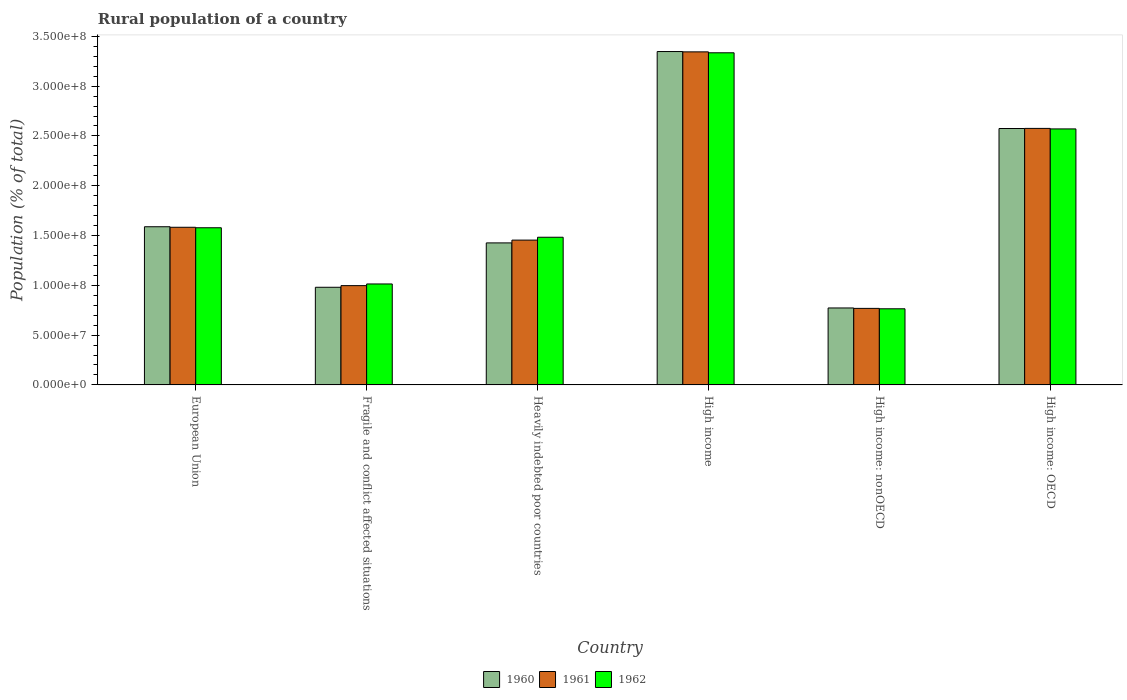How many groups of bars are there?
Your answer should be compact. 6. Are the number of bars per tick equal to the number of legend labels?
Ensure brevity in your answer.  Yes. Are the number of bars on each tick of the X-axis equal?
Make the answer very short. Yes. How many bars are there on the 4th tick from the left?
Your answer should be compact. 3. How many bars are there on the 5th tick from the right?
Ensure brevity in your answer.  3. What is the label of the 4th group of bars from the left?
Provide a succinct answer. High income. In how many cases, is the number of bars for a given country not equal to the number of legend labels?
Provide a short and direct response. 0. What is the rural population in 1961 in High income: OECD?
Offer a terse response. 2.58e+08. Across all countries, what is the maximum rural population in 1962?
Offer a terse response. 3.33e+08. Across all countries, what is the minimum rural population in 1962?
Your answer should be very brief. 7.64e+07. In which country was the rural population in 1960 maximum?
Offer a terse response. High income. In which country was the rural population in 1960 minimum?
Your answer should be compact. High income: nonOECD. What is the total rural population in 1962 in the graph?
Make the answer very short. 1.07e+09. What is the difference between the rural population in 1960 in European Union and that in Heavily indebted poor countries?
Offer a terse response. 1.62e+07. What is the difference between the rural population in 1962 in Fragile and conflict affected situations and the rural population in 1960 in High income: OECD?
Provide a short and direct response. -1.56e+08. What is the average rural population in 1960 per country?
Your answer should be compact. 1.78e+08. What is the difference between the rural population of/in 1962 and rural population of/in 1960 in European Union?
Your answer should be compact. -1.02e+06. In how many countries, is the rural population in 1960 greater than 20000000 %?
Offer a very short reply. 6. What is the ratio of the rural population in 1960 in Fragile and conflict affected situations to that in High income: OECD?
Provide a succinct answer. 0.38. Is the rural population in 1960 in Fragile and conflict affected situations less than that in High income: OECD?
Give a very brief answer. Yes. What is the difference between the highest and the second highest rural population in 1961?
Ensure brevity in your answer.  7.69e+07. What is the difference between the highest and the lowest rural population in 1961?
Provide a short and direct response. 2.58e+08. In how many countries, is the rural population in 1960 greater than the average rural population in 1960 taken over all countries?
Ensure brevity in your answer.  2. Is it the case that in every country, the sum of the rural population in 1961 and rural population in 1960 is greater than the rural population in 1962?
Provide a succinct answer. Yes. How many countries are there in the graph?
Your answer should be very brief. 6. Where does the legend appear in the graph?
Offer a terse response. Bottom center. What is the title of the graph?
Provide a succinct answer. Rural population of a country. Does "1960" appear as one of the legend labels in the graph?
Offer a very short reply. Yes. What is the label or title of the Y-axis?
Provide a succinct answer. Population (% of total). What is the Population (% of total) in 1960 in European Union?
Keep it short and to the point. 1.59e+08. What is the Population (% of total) in 1961 in European Union?
Keep it short and to the point. 1.58e+08. What is the Population (% of total) of 1962 in European Union?
Offer a very short reply. 1.58e+08. What is the Population (% of total) in 1960 in Fragile and conflict affected situations?
Offer a terse response. 9.80e+07. What is the Population (% of total) of 1961 in Fragile and conflict affected situations?
Your answer should be very brief. 9.97e+07. What is the Population (% of total) of 1962 in Fragile and conflict affected situations?
Your answer should be very brief. 1.01e+08. What is the Population (% of total) in 1960 in Heavily indebted poor countries?
Give a very brief answer. 1.43e+08. What is the Population (% of total) in 1961 in Heavily indebted poor countries?
Your answer should be compact. 1.45e+08. What is the Population (% of total) of 1962 in Heavily indebted poor countries?
Offer a terse response. 1.48e+08. What is the Population (% of total) of 1960 in High income?
Keep it short and to the point. 3.35e+08. What is the Population (% of total) of 1961 in High income?
Make the answer very short. 3.34e+08. What is the Population (% of total) in 1962 in High income?
Your response must be concise. 3.33e+08. What is the Population (% of total) of 1960 in High income: nonOECD?
Provide a succinct answer. 7.73e+07. What is the Population (% of total) in 1961 in High income: nonOECD?
Offer a terse response. 7.69e+07. What is the Population (% of total) in 1962 in High income: nonOECD?
Make the answer very short. 7.64e+07. What is the Population (% of total) of 1960 in High income: OECD?
Make the answer very short. 2.57e+08. What is the Population (% of total) in 1961 in High income: OECD?
Keep it short and to the point. 2.58e+08. What is the Population (% of total) in 1962 in High income: OECD?
Provide a short and direct response. 2.57e+08. Across all countries, what is the maximum Population (% of total) in 1960?
Your answer should be very brief. 3.35e+08. Across all countries, what is the maximum Population (% of total) in 1961?
Your answer should be compact. 3.34e+08. Across all countries, what is the maximum Population (% of total) in 1962?
Provide a succinct answer. 3.33e+08. Across all countries, what is the minimum Population (% of total) of 1960?
Keep it short and to the point. 7.73e+07. Across all countries, what is the minimum Population (% of total) in 1961?
Offer a terse response. 7.69e+07. Across all countries, what is the minimum Population (% of total) in 1962?
Provide a succinct answer. 7.64e+07. What is the total Population (% of total) in 1960 in the graph?
Provide a succinct answer. 1.07e+09. What is the total Population (% of total) in 1961 in the graph?
Provide a succinct answer. 1.07e+09. What is the total Population (% of total) in 1962 in the graph?
Keep it short and to the point. 1.07e+09. What is the difference between the Population (% of total) in 1960 in European Union and that in Fragile and conflict affected situations?
Offer a very short reply. 6.08e+07. What is the difference between the Population (% of total) in 1961 in European Union and that in Fragile and conflict affected situations?
Offer a very short reply. 5.86e+07. What is the difference between the Population (% of total) in 1962 in European Union and that in Fragile and conflict affected situations?
Provide a succinct answer. 5.64e+07. What is the difference between the Population (% of total) in 1960 in European Union and that in Heavily indebted poor countries?
Offer a very short reply. 1.62e+07. What is the difference between the Population (% of total) of 1961 in European Union and that in Heavily indebted poor countries?
Your response must be concise. 1.29e+07. What is the difference between the Population (% of total) in 1962 in European Union and that in Heavily indebted poor countries?
Your answer should be compact. 9.52e+06. What is the difference between the Population (% of total) in 1960 in European Union and that in High income?
Keep it short and to the point. -1.76e+08. What is the difference between the Population (% of total) in 1961 in European Union and that in High income?
Make the answer very short. -1.76e+08. What is the difference between the Population (% of total) of 1962 in European Union and that in High income?
Offer a very short reply. -1.76e+08. What is the difference between the Population (% of total) of 1960 in European Union and that in High income: nonOECD?
Your response must be concise. 8.16e+07. What is the difference between the Population (% of total) in 1961 in European Union and that in High income: nonOECD?
Give a very brief answer. 8.14e+07. What is the difference between the Population (% of total) in 1962 in European Union and that in High income: nonOECD?
Ensure brevity in your answer.  8.14e+07. What is the difference between the Population (% of total) in 1960 in European Union and that in High income: OECD?
Make the answer very short. -9.86e+07. What is the difference between the Population (% of total) of 1961 in European Union and that in High income: OECD?
Keep it short and to the point. -9.93e+07. What is the difference between the Population (% of total) of 1962 in European Union and that in High income: OECD?
Your response must be concise. -9.93e+07. What is the difference between the Population (% of total) in 1960 in Fragile and conflict affected situations and that in Heavily indebted poor countries?
Give a very brief answer. -4.46e+07. What is the difference between the Population (% of total) in 1961 in Fragile and conflict affected situations and that in Heavily indebted poor countries?
Provide a succinct answer. -4.57e+07. What is the difference between the Population (% of total) in 1962 in Fragile and conflict affected situations and that in Heavily indebted poor countries?
Your answer should be very brief. -4.69e+07. What is the difference between the Population (% of total) in 1960 in Fragile and conflict affected situations and that in High income?
Offer a terse response. -2.37e+08. What is the difference between the Population (% of total) of 1961 in Fragile and conflict affected situations and that in High income?
Provide a short and direct response. -2.35e+08. What is the difference between the Population (% of total) in 1962 in Fragile and conflict affected situations and that in High income?
Your answer should be very brief. -2.32e+08. What is the difference between the Population (% of total) in 1960 in Fragile and conflict affected situations and that in High income: nonOECD?
Provide a short and direct response. 2.08e+07. What is the difference between the Population (% of total) of 1961 in Fragile and conflict affected situations and that in High income: nonOECD?
Offer a very short reply. 2.28e+07. What is the difference between the Population (% of total) of 1962 in Fragile and conflict affected situations and that in High income: nonOECD?
Your response must be concise. 2.49e+07. What is the difference between the Population (% of total) in 1960 in Fragile and conflict affected situations and that in High income: OECD?
Ensure brevity in your answer.  -1.59e+08. What is the difference between the Population (% of total) of 1961 in Fragile and conflict affected situations and that in High income: OECD?
Provide a short and direct response. -1.58e+08. What is the difference between the Population (% of total) of 1962 in Fragile and conflict affected situations and that in High income: OECD?
Your answer should be compact. -1.56e+08. What is the difference between the Population (% of total) in 1960 in Heavily indebted poor countries and that in High income?
Keep it short and to the point. -1.92e+08. What is the difference between the Population (% of total) in 1961 in Heavily indebted poor countries and that in High income?
Provide a succinct answer. -1.89e+08. What is the difference between the Population (% of total) in 1962 in Heavily indebted poor countries and that in High income?
Your answer should be very brief. -1.85e+08. What is the difference between the Population (% of total) in 1960 in Heavily indebted poor countries and that in High income: nonOECD?
Keep it short and to the point. 6.53e+07. What is the difference between the Population (% of total) of 1961 in Heavily indebted poor countries and that in High income: nonOECD?
Your answer should be very brief. 6.86e+07. What is the difference between the Population (% of total) in 1962 in Heavily indebted poor countries and that in High income: nonOECD?
Your answer should be compact. 7.19e+07. What is the difference between the Population (% of total) in 1960 in Heavily indebted poor countries and that in High income: OECD?
Offer a terse response. -1.15e+08. What is the difference between the Population (% of total) of 1961 in Heavily indebted poor countries and that in High income: OECD?
Offer a terse response. -1.12e+08. What is the difference between the Population (% of total) in 1962 in Heavily indebted poor countries and that in High income: OECD?
Provide a short and direct response. -1.09e+08. What is the difference between the Population (% of total) in 1960 in High income and that in High income: nonOECD?
Provide a succinct answer. 2.57e+08. What is the difference between the Population (% of total) in 1961 in High income and that in High income: nonOECD?
Keep it short and to the point. 2.58e+08. What is the difference between the Population (% of total) of 1962 in High income and that in High income: nonOECD?
Your response must be concise. 2.57e+08. What is the difference between the Population (% of total) of 1960 in High income and that in High income: OECD?
Make the answer very short. 7.73e+07. What is the difference between the Population (% of total) of 1961 in High income and that in High income: OECD?
Your answer should be very brief. 7.69e+07. What is the difference between the Population (% of total) in 1962 in High income and that in High income: OECD?
Keep it short and to the point. 7.64e+07. What is the difference between the Population (% of total) in 1960 in High income: nonOECD and that in High income: OECD?
Give a very brief answer. -1.80e+08. What is the difference between the Population (% of total) in 1961 in High income: nonOECD and that in High income: OECD?
Provide a short and direct response. -1.81e+08. What is the difference between the Population (% of total) in 1962 in High income: nonOECD and that in High income: OECD?
Keep it short and to the point. -1.81e+08. What is the difference between the Population (% of total) of 1960 in European Union and the Population (% of total) of 1961 in Fragile and conflict affected situations?
Your answer should be very brief. 5.91e+07. What is the difference between the Population (% of total) in 1960 in European Union and the Population (% of total) in 1962 in Fragile and conflict affected situations?
Keep it short and to the point. 5.75e+07. What is the difference between the Population (% of total) in 1961 in European Union and the Population (% of total) in 1962 in Fragile and conflict affected situations?
Offer a terse response. 5.69e+07. What is the difference between the Population (% of total) in 1960 in European Union and the Population (% of total) in 1961 in Heavily indebted poor countries?
Provide a succinct answer. 1.34e+07. What is the difference between the Population (% of total) in 1960 in European Union and the Population (% of total) in 1962 in Heavily indebted poor countries?
Give a very brief answer. 1.05e+07. What is the difference between the Population (% of total) in 1961 in European Union and the Population (% of total) in 1962 in Heavily indebted poor countries?
Keep it short and to the point. 1.00e+07. What is the difference between the Population (% of total) of 1960 in European Union and the Population (% of total) of 1961 in High income?
Your response must be concise. -1.76e+08. What is the difference between the Population (% of total) in 1960 in European Union and the Population (% of total) in 1962 in High income?
Your answer should be very brief. -1.75e+08. What is the difference between the Population (% of total) of 1961 in European Union and the Population (% of total) of 1962 in High income?
Keep it short and to the point. -1.75e+08. What is the difference between the Population (% of total) of 1960 in European Union and the Population (% of total) of 1961 in High income: nonOECD?
Give a very brief answer. 8.20e+07. What is the difference between the Population (% of total) of 1960 in European Union and the Population (% of total) of 1962 in High income: nonOECD?
Provide a short and direct response. 8.24e+07. What is the difference between the Population (% of total) of 1961 in European Union and the Population (% of total) of 1962 in High income: nonOECD?
Your answer should be compact. 8.19e+07. What is the difference between the Population (% of total) of 1960 in European Union and the Population (% of total) of 1961 in High income: OECD?
Your response must be concise. -9.87e+07. What is the difference between the Population (% of total) in 1960 in European Union and the Population (% of total) in 1962 in High income: OECD?
Ensure brevity in your answer.  -9.82e+07. What is the difference between the Population (% of total) in 1961 in European Union and the Population (% of total) in 1962 in High income: OECD?
Keep it short and to the point. -9.88e+07. What is the difference between the Population (% of total) of 1960 in Fragile and conflict affected situations and the Population (% of total) of 1961 in Heavily indebted poor countries?
Give a very brief answer. -4.74e+07. What is the difference between the Population (% of total) in 1960 in Fragile and conflict affected situations and the Population (% of total) in 1962 in Heavily indebted poor countries?
Offer a very short reply. -5.02e+07. What is the difference between the Population (% of total) of 1961 in Fragile and conflict affected situations and the Population (% of total) of 1962 in Heavily indebted poor countries?
Provide a succinct answer. -4.86e+07. What is the difference between the Population (% of total) in 1960 in Fragile and conflict affected situations and the Population (% of total) in 1961 in High income?
Offer a very short reply. -2.36e+08. What is the difference between the Population (% of total) in 1960 in Fragile and conflict affected situations and the Population (% of total) in 1962 in High income?
Offer a very short reply. -2.35e+08. What is the difference between the Population (% of total) in 1961 in Fragile and conflict affected situations and the Population (% of total) in 1962 in High income?
Keep it short and to the point. -2.34e+08. What is the difference between the Population (% of total) in 1960 in Fragile and conflict affected situations and the Population (% of total) in 1961 in High income: nonOECD?
Ensure brevity in your answer.  2.12e+07. What is the difference between the Population (% of total) in 1960 in Fragile and conflict affected situations and the Population (% of total) in 1962 in High income: nonOECD?
Offer a terse response. 2.16e+07. What is the difference between the Population (% of total) in 1961 in Fragile and conflict affected situations and the Population (% of total) in 1962 in High income: nonOECD?
Your response must be concise. 2.33e+07. What is the difference between the Population (% of total) of 1960 in Fragile and conflict affected situations and the Population (% of total) of 1961 in High income: OECD?
Provide a short and direct response. -1.60e+08. What is the difference between the Population (% of total) of 1960 in Fragile and conflict affected situations and the Population (% of total) of 1962 in High income: OECD?
Your response must be concise. -1.59e+08. What is the difference between the Population (% of total) of 1961 in Fragile and conflict affected situations and the Population (% of total) of 1962 in High income: OECD?
Your answer should be compact. -1.57e+08. What is the difference between the Population (% of total) of 1960 in Heavily indebted poor countries and the Population (% of total) of 1961 in High income?
Offer a terse response. -1.92e+08. What is the difference between the Population (% of total) of 1960 in Heavily indebted poor countries and the Population (% of total) of 1962 in High income?
Your answer should be very brief. -1.91e+08. What is the difference between the Population (% of total) in 1961 in Heavily indebted poor countries and the Population (% of total) in 1962 in High income?
Give a very brief answer. -1.88e+08. What is the difference between the Population (% of total) of 1960 in Heavily indebted poor countries and the Population (% of total) of 1961 in High income: nonOECD?
Give a very brief answer. 6.58e+07. What is the difference between the Population (% of total) of 1960 in Heavily indebted poor countries and the Population (% of total) of 1962 in High income: nonOECD?
Your answer should be very brief. 6.62e+07. What is the difference between the Population (% of total) in 1961 in Heavily indebted poor countries and the Population (% of total) in 1962 in High income: nonOECD?
Offer a terse response. 6.90e+07. What is the difference between the Population (% of total) of 1960 in Heavily indebted poor countries and the Population (% of total) of 1961 in High income: OECD?
Your response must be concise. -1.15e+08. What is the difference between the Population (% of total) in 1960 in Heavily indebted poor countries and the Population (% of total) in 1962 in High income: OECD?
Ensure brevity in your answer.  -1.14e+08. What is the difference between the Population (% of total) in 1961 in Heavily indebted poor countries and the Population (% of total) in 1962 in High income: OECD?
Your answer should be compact. -1.12e+08. What is the difference between the Population (% of total) in 1960 in High income and the Population (% of total) in 1961 in High income: nonOECD?
Offer a terse response. 2.58e+08. What is the difference between the Population (% of total) in 1960 in High income and the Population (% of total) in 1962 in High income: nonOECD?
Offer a terse response. 2.58e+08. What is the difference between the Population (% of total) in 1961 in High income and the Population (% of total) in 1962 in High income: nonOECD?
Your response must be concise. 2.58e+08. What is the difference between the Population (% of total) of 1960 in High income and the Population (% of total) of 1961 in High income: OECD?
Provide a succinct answer. 7.72e+07. What is the difference between the Population (% of total) of 1960 in High income and the Population (% of total) of 1962 in High income: OECD?
Your answer should be very brief. 7.77e+07. What is the difference between the Population (% of total) in 1961 in High income and the Population (% of total) in 1962 in High income: OECD?
Provide a short and direct response. 7.74e+07. What is the difference between the Population (% of total) in 1960 in High income: nonOECD and the Population (% of total) in 1961 in High income: OECD?
Your answer should be compact. -1.80e+08. What is the difference between the Population (% of total) in 1960 in High income: nonOECD and the Population (% of total) in 1962 in High income: OECD?
Offer a terse response. -1.80e+08. What is the difference between the Population (% of total) in 1961 in High income: nonOECD and the Population (% of total) in 1962 in High income: OECD?
Provide a succinct answer. -1.80e+08. What is the average Population (% of total) in 1960 per country?
Make the answer very short. 1.78e+08. What is the average Population (% of total) in 1961 per country?
Keep it short and to the point. 1.79e+08. What is the average Population (% of total) in 1962 per country?
Make the answer very short. 1.79e+08. What is the difference between the Population (% of total) in 1960 and Population (% of total) in 1961 in European Union?
Offer a very short reply. 5.42e+05. What is the difference between the Population (% of total) of 1960 and Population (% of total) of 1962 in European Union?
Ensure brevity in your answer.  1.02e+06. What is the difference between the Population (% of total) of 1961 and Population (% of total) of 1962 in European Union?
Your response must be concise. 4.81e+05. What is the difference between the Population (% of total) in 1960 and Population (% of total) in 1961 in Fragile and conflict affected situations?
Your answer should be compact. -1.65e+06. What is the difference between the Population (% of total) in 1960 and Population (% of total) in 1962 in Fragile and conflict affected situations?
Provide a succinct answer. -3.33e+06. What is the difference between the Population (% of total) of 1961 and Population (% of total) of 1962 in Fragile and conflict affected situations?
Offer a very short reply. -1.68e+06. What is the difference between the Population (% of total) of 1960 and Population (% of total) of 1961 in Heavily indebted poor countries?
Your response must be concise. -2.80e+06. What is the difference between the Population (% of total) of 1960 and Population (% of total) of 1962 in Heavily indebted poor countries?
Ensure brevity in your answer.  -5.68e+06. What is the difference between the Population (% of total) in 1961 and Population (% of total) in 1962 in Heavily indebted poor countries?
Your answer should be very brief. -2.88e+06. What is the difference between the Population (% of total) of 1960 and Population (% of total) of 1961 in High income?
Provide a succinct answer. 3.18e+05. What is the difference between the Population (% of total) of 1960 and Population (% of total) of 1962 in High income?
Provide a succinct answer. 1.25e+06. What is the difference between the Population (% of total) of 1961 and Population (% of total) of 1962 in High income?
Your answer should be compact. 9.36e+05. What is the difference between the Population (% of total) in 1960 and Population (% of total) in 1961 in High income: nonOECD?
Offer a very short reply. 4.24e+05. What is the difference between the Population (% of total) in 1960 and Population (% of total) in 1962 in High income: nonOECD?
Your answer should be compact. 8.42e+05. What is the difference between the Population (% of total) in 1961 and Population (% of total) in 1962 in High income: nonOECD?
Keep it short and to the point. 4.18e+05. What is the difference between the Population (% of total) in 1960 and Population (% of total) in 1961 in High income: OECD?
Your answer should be compact. -1.05e+05. What is the difference between the Population (% of total) in 1960 and Population (% of total) in 1962 in High income: OECD?
Your answer should be very brief. 4.13e+05. What is the difference between the Population (% of total) of 1961 and Population (% of total) of 1962 in High income: OECD?
Provide a short and direct response. 5.18e+05. What is the ratio of the Population (% of total) of 1960 in European Union to that in Fragile and conflict affected situations?
Provide a short and direct response. 1.62. What is the ratio of the Population (% of total) in 1961 in European Union to that in Fragile and conflict affected situations?
Ensure brevity in your answer.  1.59. What is the ratio of the Population (% of total) in 1962 in European Union to that in Fragile and conflict affected situations?
Your answer should be compact. 1.56. What is the ratio of the Population (% of total) of 1960 in European Union to that in Heavily indebted poor countries?
Give a very brief answer. 1.11. What is the ratio of the Population (% of total) of 1961 in European Union to that in Heavily indebted poor countries?
Offer a terse response. 1.09. What is the ratio of the Population (% of total) in 1962 in European Union to that in Heavily indebted poor countries?
Make the answer very short. 1.06. What is the ratio of the Population (% of total) in 1960 in European Union to that in High income?
Give a very brief answer. 0.47. What is the ratio of the Population (% of total) of 1961 in European Union to that in High income?
Provide a short and direct response. 0.47. What is the ratio of the Population (% of total) of 1962 in European Union to that in High income?
Ensure brevity in your answer.  0.47. What is the ratio of the Population (% of total) of 1960 in European Union to that in High income: nonOECD?
Provide a short and direct response. 2.06. What is the ratio of the Population (% of total) in 1961 in European Union to that in High income: nonOECD?
Provide a succinct answer. 2.06. What is the ratio of the Population (% of total) in 1962 in European Union to that in High income: nonOECD?
Make the answer very short. 2.06. What is the ratio of the Population (% of total) in 1960 in European Union to that in High income: OECD?
Provide a short and direct response. 0.62. What is the ratio of the Population (% of total) in 1961 in European Union to that in High income: OECD?
Offer a very short reply. 0.61. What is the ratio of the Population (% of total) in 1962 in European Union to that in High income: OECD?
Give a very brief answer. 0.61. What is the ratio of the Population (% of total) in 1960 in Fragile and conflict affected situations to that in Heavily indebted poor countries?
Keep it short and to the point. 0.69. What is the ratio of the Population (% of total) in 1961 in Fragile and conflict affected situations to that in Heavily indebted poor countries?
Your response must be concise. 0.69. What is the ratio of the Population (% of total) in 1962 in Fragile and conflict affected situations to that in Heavily indebted poor countries?
Keep it short and to the point. 0.68. What is the ratio of the Population (% of total) of 1960 in Fragile and conflict affected situations to that in High income?
Provide a short and direct response. 0.29. What is the ratio of the Population (% of total) of 1961 in Fragile and conflict affected situations to that in High income?
Your response must be concise. 0.3. What is the ratio of the Population (% of total) of 1962 in Fragile and conflict affected situations to that in High income?
Provide a succinct answer. 0.3. What is the ratio of the Population (% of total) of 1960 in Fragile and conflict affected situations to that in High income: nonOECD?
Make the answer very short. 1.27. What is the ratio of the Population (% of total) in 1961 in Fragile and conflict affected situations to that in High income: nonOECD?
Offer a very short reply. 1.3. What is the ratio of the Population (% of total) in 1962 in Fragile and conflict affected situations to that in High income: nonOECD?
Ensure brevity in your answer.  1.33. What is the ratio of the Population (% of total) of 1960 in Fragile and conflict affected situations to that in High income: OECD?
Your answer should be very brief. 0.38. What is the ratio of the Population (% of total) in 1961 in Fragile and conflict affected situations to that in High income: OECD?
Give a very brief answer. 0.39. What is the ratio of the Population (% of total) of 1962 in Fragile and conflict affected situations to that in High income: OECD?
Give a very brief answer. 0.39. What is the ratio of the Population (% of total) of 1960 in Heavily indebted poor countries to that in High income?
Your answer should be very brief. 0.43. What is the ratio of the Population (% of total) in 1961 in Heavily indebted poor countries to that in High income?
Ensure brevity in your answer.  0.43. What is the ratio of the Population (% of total) of 1962 in Heavily indebted poor countries to that in High income?
Give a very brief answer. 0.44. What is the ratio of the Population (% of total) in 1960 in Heavily indebted poor countries to that in High income: nonOECD?
Your answer should be compact. 1.85. What is the ratio of the Population (% of total) in 1961 in Heavily indebted poor countries to that in High income: nonOECD?
Make the answer very short. 1.89. What is the ratio of the Population (% of total) of 1962 in Heavily indebted poor countries to that in High income: nonOECD?
Provide a short and direct response. 1.94. What is the ratio of the Population (% of total) in 1960 in Heavily indebted poor countries to that in High income: OECD?
Your answer should be very brief. 0.55. What is the ratio of the Population (% of total) in 1961 in Heavily indebted poor countries to that in High income: OECD?
Keep it short and to the point. 0.56. What is the ratio of the Population (% of total) of 1962 in Heavily indebted poor countries to that in High income: OECD?
Offer a terse response. 0.58. What is the ratio of the Population (% of total) in 1960 in High income to that in High income: nonOECD?
Offer a very short reply. 4.33. What is the ratio of the Population (% of total) of 1961 in High income to that in High income: nonOECD?
Your answer should be compact. 4.35. What is the ratio of the Population (% of total) of 1962 in High income to that in High income: nonOECD?
Ensure brevity in your answer.  4.36. What is the ratio of the Population (% of total) in 1960 in High income to that in High income: OECD?
Ensure brevity in your answer.  1.3. What is the ratio of the Population (% of total) in 1961 in High income to that in High income: OECD?
Give a very brief answer. 1.3. What is the ratio of the Population (% of total) of 1962 in High income to that in High income: OECD?
Give a very brief answer. 1.3. What is the ratio of the Population (% of total) in 1960 in High income: nonOECD to that in High income: OECD?
Your answer should be very brief. 0.3. What is the ratio of the Population (% of total) in 1961 in High income: nonOECD to that in High income: OECD?
Provide a succinct answer. 0.3. What is the ratio of the Population (% of total) in 1962 in High income: nonOECD to that in High income: OECD?
Give a very brief answer. 0.3. What is the difference between the highest and the second highest Population (% of total) of 1960?
Ensure brevity in your answer.  7.73e+07. What is the difference between the highest and the second highest Population (% of total) in 1961?
Keep it short and to the point. 7.69e+07. What is the difference between the highest and the second highest Population (% of total) in 1962?
Offer a very short reply. 7.64e+07. What is the difference between the highest and the lowest Population (% of total) of 1960?
Give a very brief answer. 2.57e+08. What is the difference between the highest and the lowest Population (% of total) in 1961?
Offer a terse response. 2.58e+08. What is the difference between the highest and the lowest Population (% of total) of 1962?
Offer a terse response. 2.57e+08. 